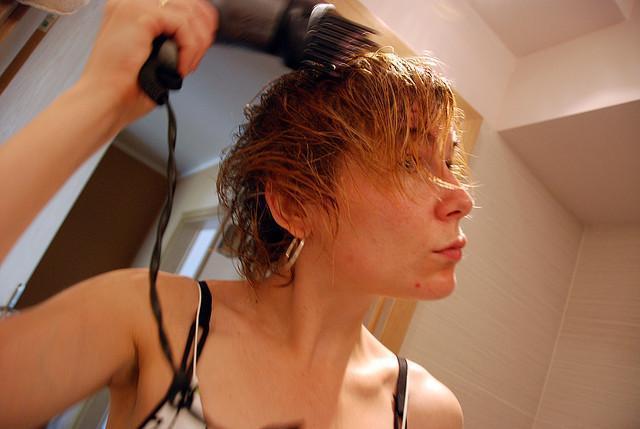How many people are wearing orange shirts in the picture?
Give a very brief answer. 0. 